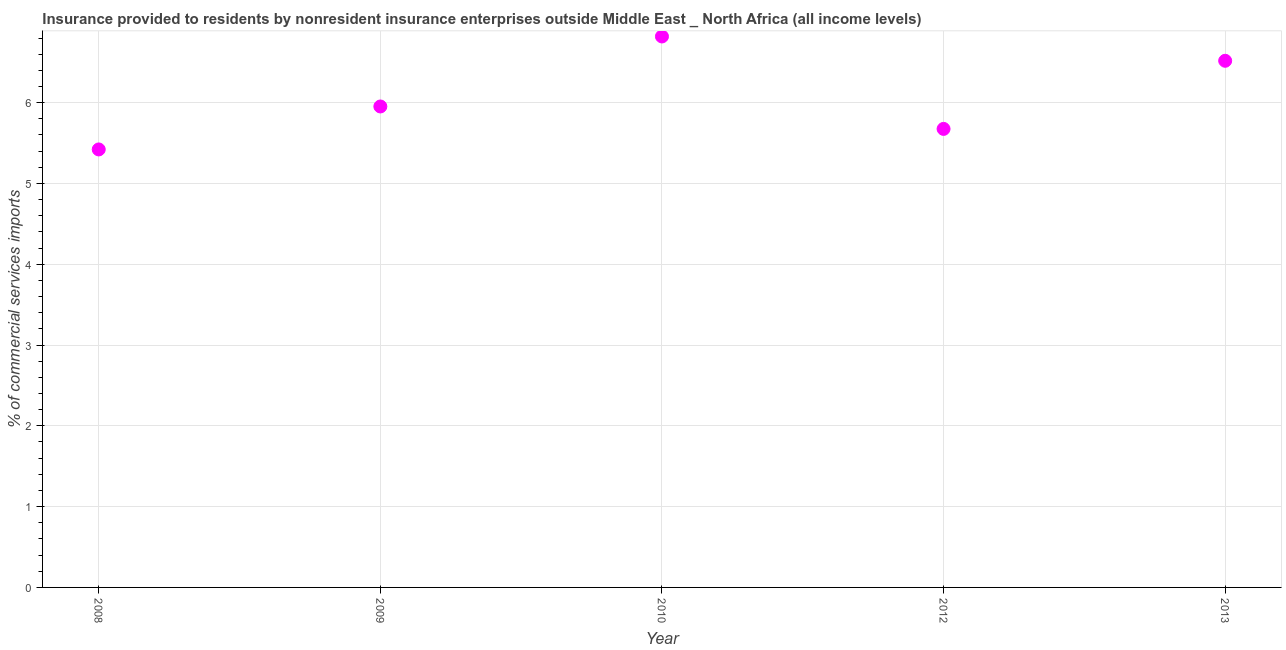What is the insurance provided by non-residents in 2008?
Give a very brief answer. 5.42. Across all years, what is the maximum insurance provided by non-residents?
Make the answer very short. 6.82. Across all years, what is the minimum insurance provided by non-residents?
Your response must be concise. 5.42. What is the sum of the insurance provided by non-residents?
Make the answer very short. 30.39. What is the difference between the insurance provided by non-residents in 2008 and 2010?
Offer a terse response. -1.4. What is the average insurance provided by non-residents per year?
Your response must be concise. 6.08. What is the median insurance provided by non-residents?
Your response must be concise. 5.95. What is the ratio of the insurance provided by non-residents in 2008 to that in 2012?
Give a very brief answer. 0.96. Is the insurance provided by non-residents in 2010 less than that in 2013?
Your answer should be compact. No. What is the difference between the highest and the second highest insurance provided by non-residents?
Keep it short and to the point. 0.3. Is the sum of the insurance provided by non-residents in 2010 and 2012 greater than the maximum insurance provided by non-residents across all years?
Your answer should be compact. Yes. What is the difference between the highest and the lowest insurance provided by non-residents?
Offer a very short reply. 1.4. In how many years, is the insurance provided by non-residents greater than the average insurance provided by non-residents taken over all years?
Provide a short and direct response. 2. Does the insurance provided by non-residents monotonically increase over the years?
Offer a terse response. No. How many years are there in the graph?
Your response must be concise. 5. Does the graph contain any zero values?
Offer a terse response. No. Does the graph contain grids?
Make the answer very short. Yes. What is the title of the graph?
Your answer should be very brief. Insurance provided to residents by nonresident insurance enterprises outside Middle East _ North Africa (all income levels). What is the label or title of the X-axis?
Your response must be concise. Year. What is the label or title of the Y-axis?
Keep it short and to the point. % of commercial services imports. What is the % of commercial services imports in 2008?
Provide a succinct answer. 5.42. What is the % of commercial services imports in 2009?
Make the answer very short. 5.95. What is the % of commercial services imports in 2010?
Your answer should be very brief. 6.82. What is the % of commercial services imports in 2012?
Make the answer very short. 5.68. What is the % of commercial services imports in 2013?
Make the answer very short. 6.52. What is the difference between the % of commercial services imports in 2008 and 2009?
Your answer should be compact. -0.53. What is the difference between the % of commercial services imports in 2008 and 2010?
Your response must be concise. -1.4. What is the difference between the % of commercial services imports in 2008 and 2012?
Provide a succinct answer. -0.25. What is the difference between the % of commercial services imports in 2008 and 2013?
Give a very brief answer. -1.1. What is the difference between the % of commercial services imports in 2009 and 2010?
Give a very brief answer. -0.87. What is the difference between the % of commercial services imports in 2009 and 2012?
Your answer should be compact. 0.28. What is the difference between the % of commercial services imports in 2009 and 2013?
Offer a terse response. -0.57. What is the difference between the % of commercial services imports in 2010 and 2012?
Your answer should be compact. 1.14. What is the difference between the % of commercial services imports in 2010 and 2013?
Your answer should be very brief. 0.3. What is the difference between the % of commercial services imports in 2012 and 2013?
Make the answer very short. -0.84. What is the ratio of the % of commercial services imports in 2008 to that in 2009?
Your response must be concise. 0.91. What is the ratio of the % of commercial services imports in 2008 to that in 2010?
Give a very brief answer. 0.8. What is the ratio of the % of commercial services imports in 2008 to that in 2012?
Offer a very short reply. 0.95. What is the ratio of the % of commercial services imports in 2008 to that in 2013?
Keep it short and to the point. 0.83. What is the ratio of the % of commercial services imports in 2009 to that in 2010?
Provide a succinct answer. 0.87. What is the ratio of the % of commercial services imports in 2009 to that in 2012?
Make the answer very short. 1.05. What is the ratio of the % of commercial services imports in 2009 to that in 2013?
Provide a succinct answer. 0.91. What is the ratio of the % of commercial services imports in 2010 to that in 2012?
Make the answer very short. 1.2. What is the ratio of the % of commercial services imports in 2010 to that in 2013?
Your answer should be compact. 1.05. What is the ratio of the % of commercial services imports in 2012 to that in 2013?
Offer a terse response. 0.87. 